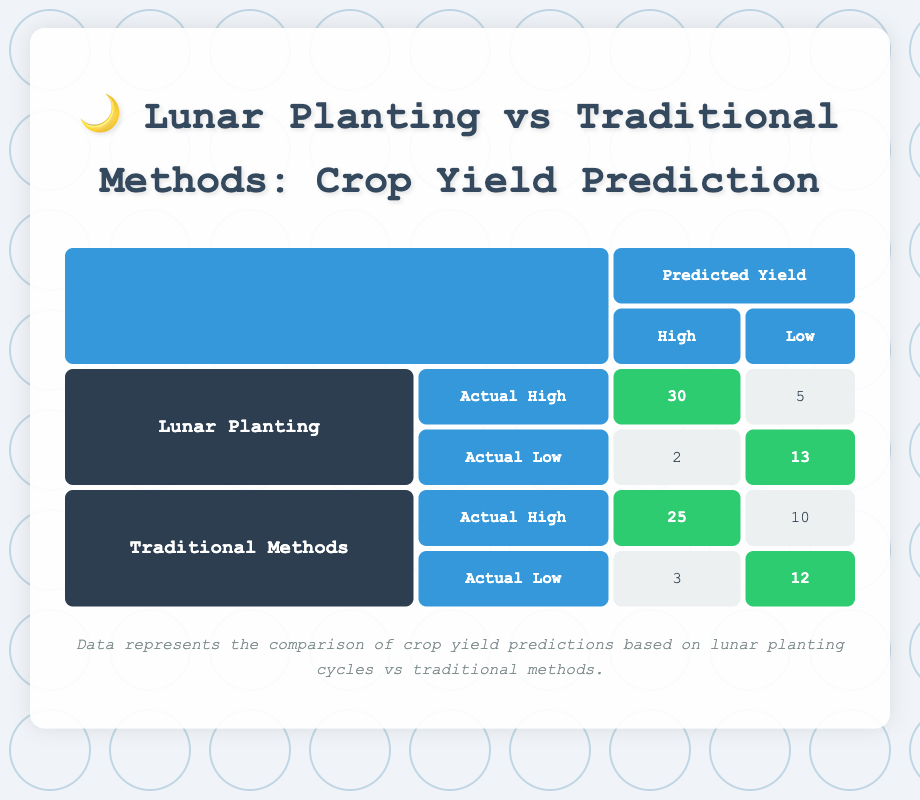What is the total count of predicted High yields for Lunar Planting method? In the table, for the Lunar Planting method, the predicted High yields are represented by the cells corresponding to both actual High and Low yields. The counts are 30 (actual High) and 2 (actual Low). Summing these gives us 30 + 2 = 32.
Answer: 32 What is the count of actual Low yields predicted as Low using Traditional Methods? For Traditional Methods, to find the count of actual Low yields that were also predicted as Low, we look at the corresponding cell in the table. This cell shows a count of 12.
Answer: 12 Is the count of actual High yields predicted as High higher for Traditional Methods compared to Lunar Planting? The count of actual High yields predicted as High for Traditional Methods is 25, while for Lunar Planting it is 30. Since 30 is higher than 25, the answer is no.
Answer: No What is the difference in count between actual High yields predicted as High for Lunar Planting and Traditional Methods? The count for Lunar Planting predicting High is 30, and for Traditional Methods, it is 25. The difference can be calculated by subtracting 25 from 30, giving us 30 - 25 = 5.
Answer: 5 What percentage of actual High yields were correctly predicted as High for Lunar Planting? To find the percentage of actual High yields correctly predicted as High for Lunar Planting, we take the count of correct predictions (30) and divide it by the total actual High yields (30 + 5 = 35), and multiply by 100. So, (30 / 35) * 100 ≈ 85.71%.
Answer: 85.71% How many more actual Low yields were predicted as Low using Lunar Planting compared to Traditional Methods? For Lunar Planting, the count of actual Low yields predicted as Low is 13, while for Traditional Methods, it is 12. To find the difference, we subtract 12 from 13, resulting in 13 - 12 = 1.
Answer: 1 What is the total count of actual yields predicted as Low across both methods? We need to sum the counts of actual yields predicted as Low for both methods. For Lunar Planting, the counts are 5 (from actual High) and 13 (from actual Low), giving us 5 + 13 = 18. For Traditional Methods, the counts are 10 (from actual High) and 12 (from actual Low), giving us 10 + 12 = 22. Therefore, the total is 18 + 22 = 40.
Answer: 40 Does the Lunar Planting method show a higher accuracy in predicting actual yields compared to Traditional Methods? To determine this, we calculate overall accuracy for both methods. Lunar Planting correctly predicted 30 + 13 = 43 out of a total of 50 (30 + 5 + 2 + 13). Traditional Methods correctly predicted 25 + 12 = 37 out of 50 (25 + 10 + 3 + 12). Thus, Lunar Planting (86%) is higher than Traditional Methods (74%).
Answer: Yes 